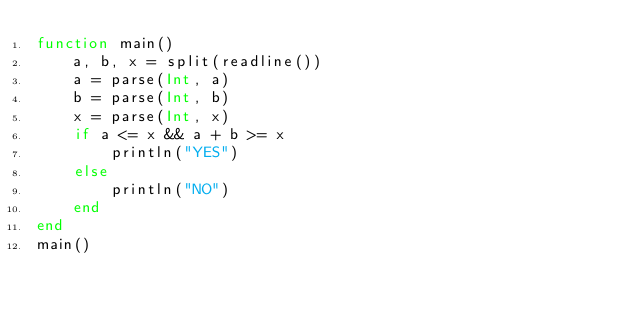Convert code to text. <code><loc_0><loc_0><loc_500><loc_500><_Julia_>function main()
    a, b, x = split(readline())
    a = parse(Int, a)
    b = parse(Int, b)
    x = parse(Int, x)    
    if a <= x && a + b >= x
        println("YES")
    else
        println("NO")
    end
end
main()</code> 